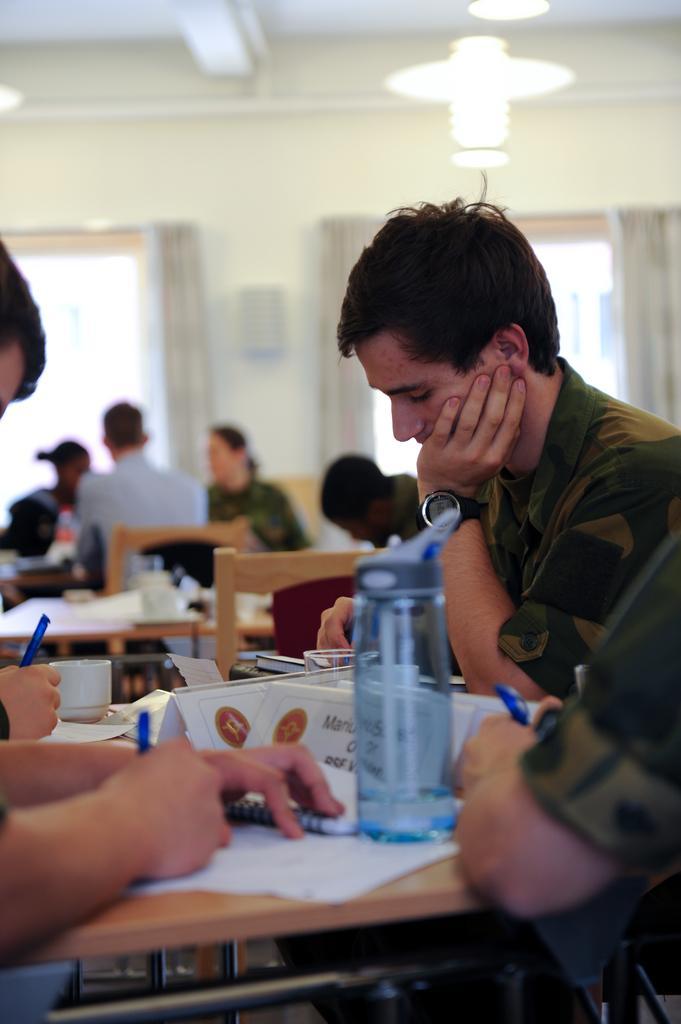In one or two sentences, can you explain what this image depicts? In this image we can see people sitting on the chairs. There are papers, bottles and other objects are kept on a table. There is a wall in the background. We can see doors in the middle of this image. 